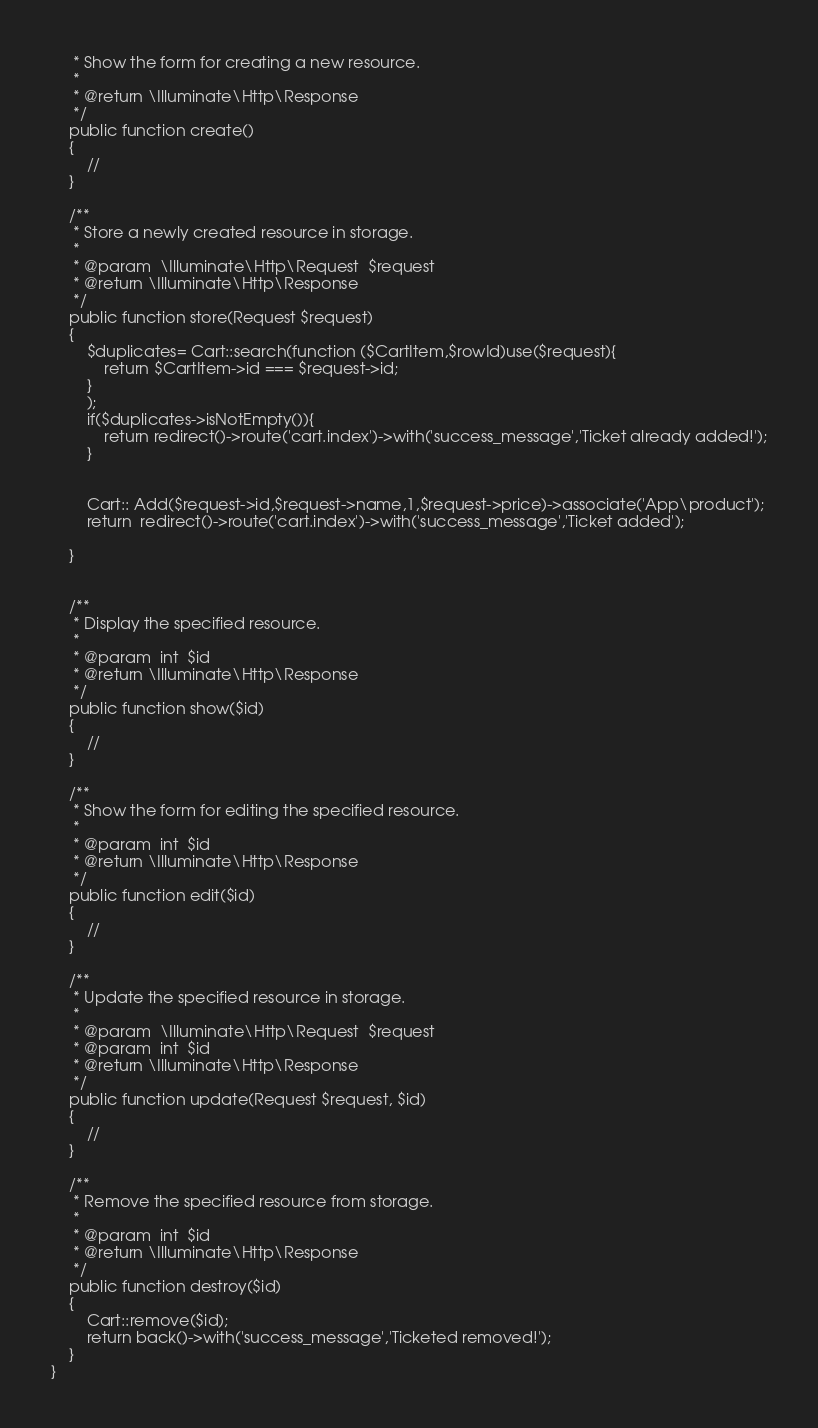Convert code to text. <code><loc_0><loc_0><loc_500><loc_500><_PHP_>     * Show the form for creating a new resource.
     *
     * @return \Illuminate\Http\Response
     */
    public function create()
    {
        //
    }

    /**
     * Store a newly created resource in storage.
     *
     * @param  \Illuminate\Http\Request  $request
     * @return \Illuminate\Http\Response
     */
    public function store(Request $request)
    {
        $duplicates= Cart::search(function ($CartItem,$rowId)use($request){
            return $CartItem->id === $request->id;
        }
        );
        if($duplicates->isNotEmpty()){
            return redirect()->route('cart.index')->with('success_message','Ticket already added!');
        }


        Cart:: Add($request->id,$request->name,1,$request->price)->associate('App\product');
        return  redirect()->route('cart.index')->with('success_message','Ticket added');

    }


    /**
     * Display the specified resource.
     *
     * @param  int  $id
     * @return \Illuminate\Http\Response
     */
    public function show($id)
    {
        //
    }

    /**
     * Show the form for editing the specified resource.
     *
     * @param  int  $id
     * @return \Illuminate\Http\Response
     */
    public function edit($id)
    {
        //
    }

    /**
     * Update the specified resource in storage.
     *
     * @param  \Illuminate\Http\Request  $request
     * @param  int  $id
     * @return \Illuminate\Http\Response
     */
    public function update(Request $request, $id)
    {
        //
    }

    /**
     * Remove the specified resource from storage.
     *
     * @param  int  $id
     * @return \Illuminate\Http\Response
     */
    public function destroy($id)
    {
        Cart::remove($id);
        return back()->with('success_message','Ticketed removed!');
    }
}
</code> 